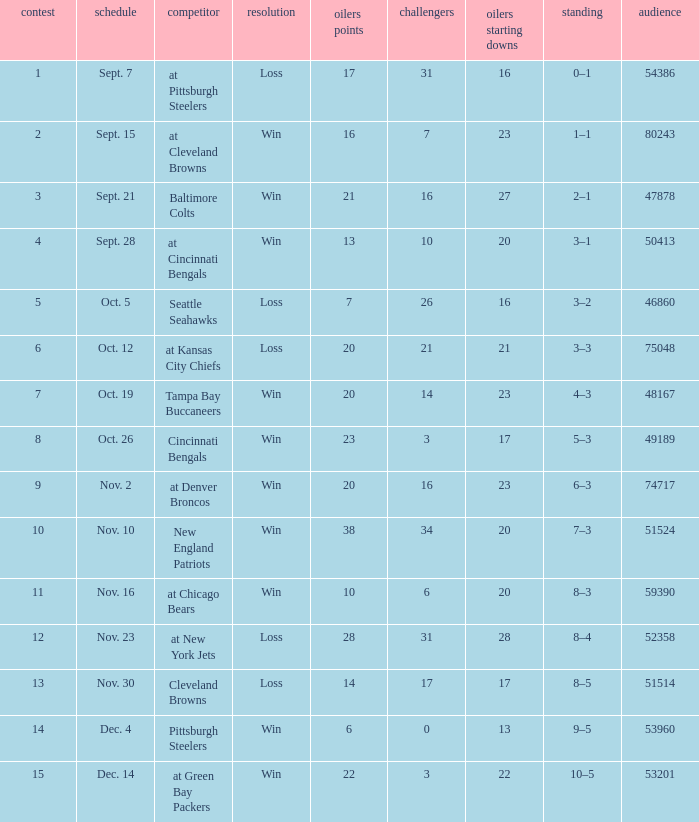What was the total opponents points for the game were the Oilers scored 21? 16.0. 